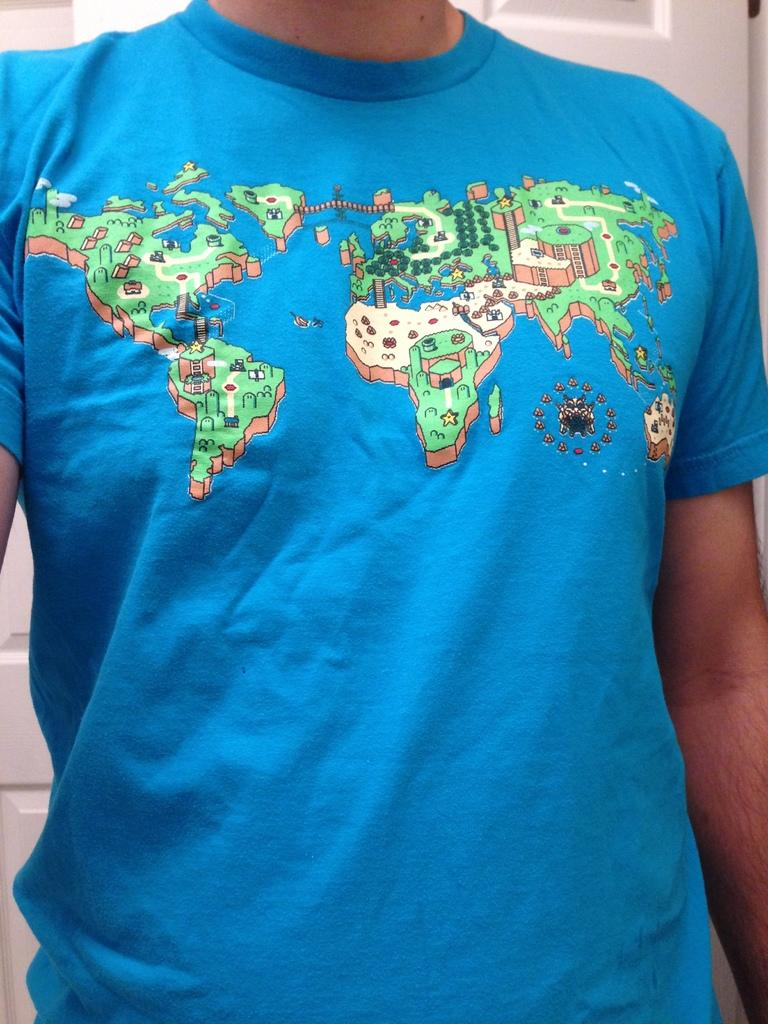Who or what is present in the image? There is a person in the image. What is the person wearing? The person is wearing a blue t-shirt. Can you describe any details on the t-shirt? Yes, there is a map on the t-shirt. What type of shade does the person in the image prefer? There is no information about the person's shade preference in the image. What work-related tasks is the person in the image performing? There is no indication of the person performing any work-related tasks in the image. 